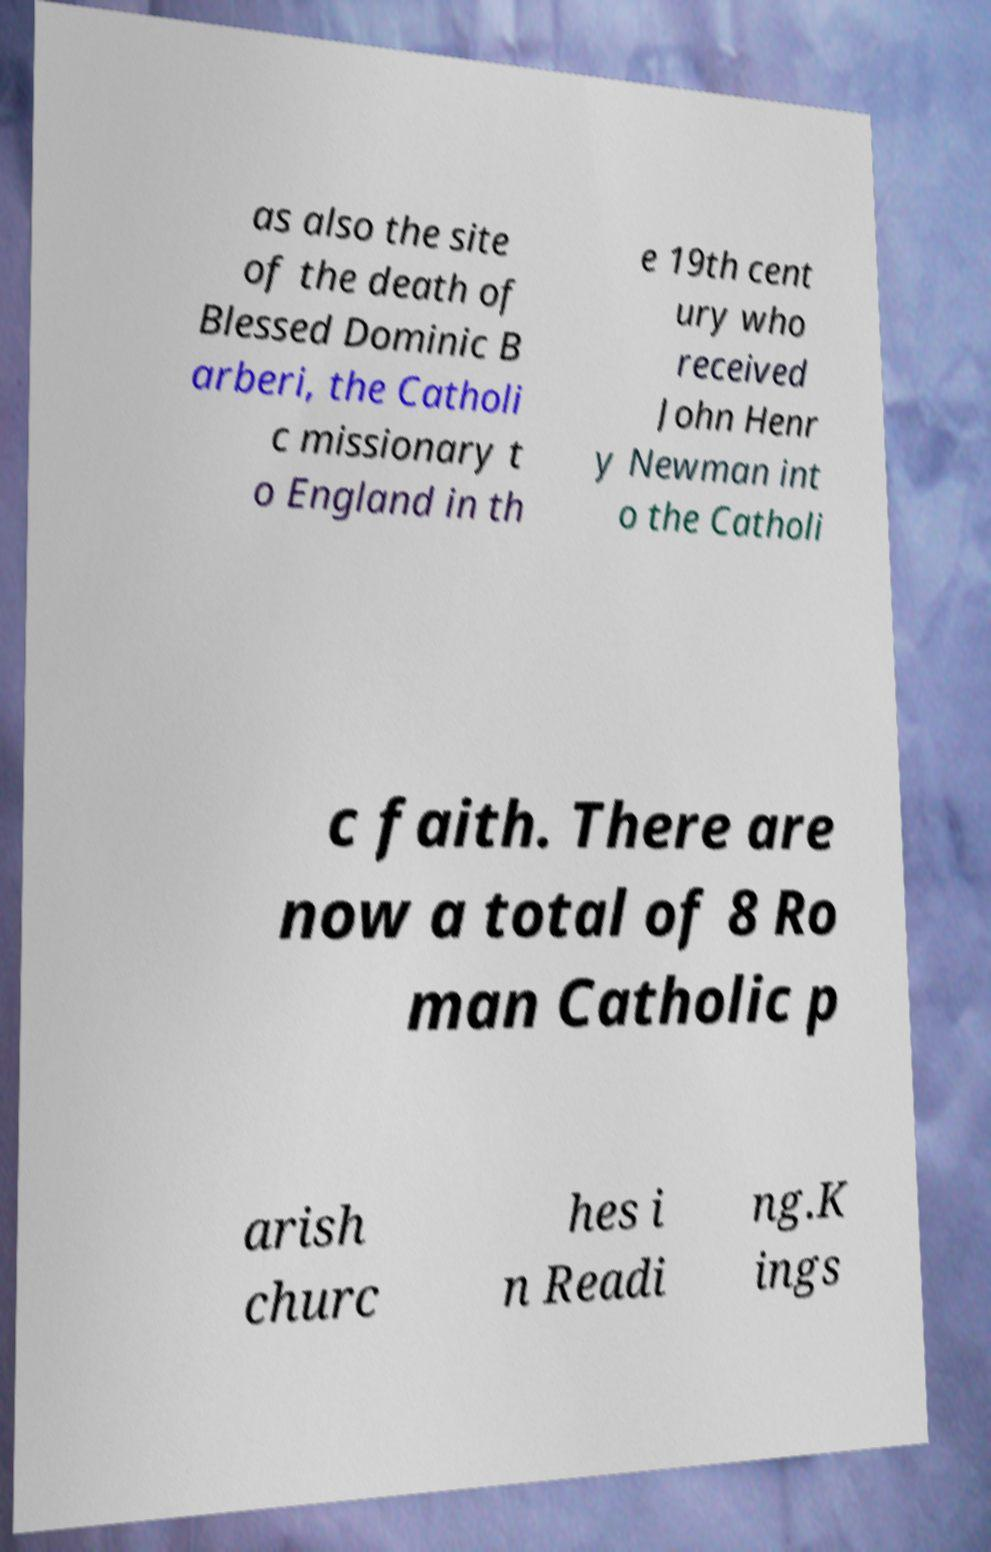What messages or text are displayed in this image? I need them in a readable, typed format. as also the site of the death of Blessed Dominic B arberi, the Catholi c missionary t o England in th e 19th cent ury who received John Henr y Newman int o the Catholi c faith. There are now a total of 8 Ro man Catholic p arish churc hes i n Readi ng.K ings 